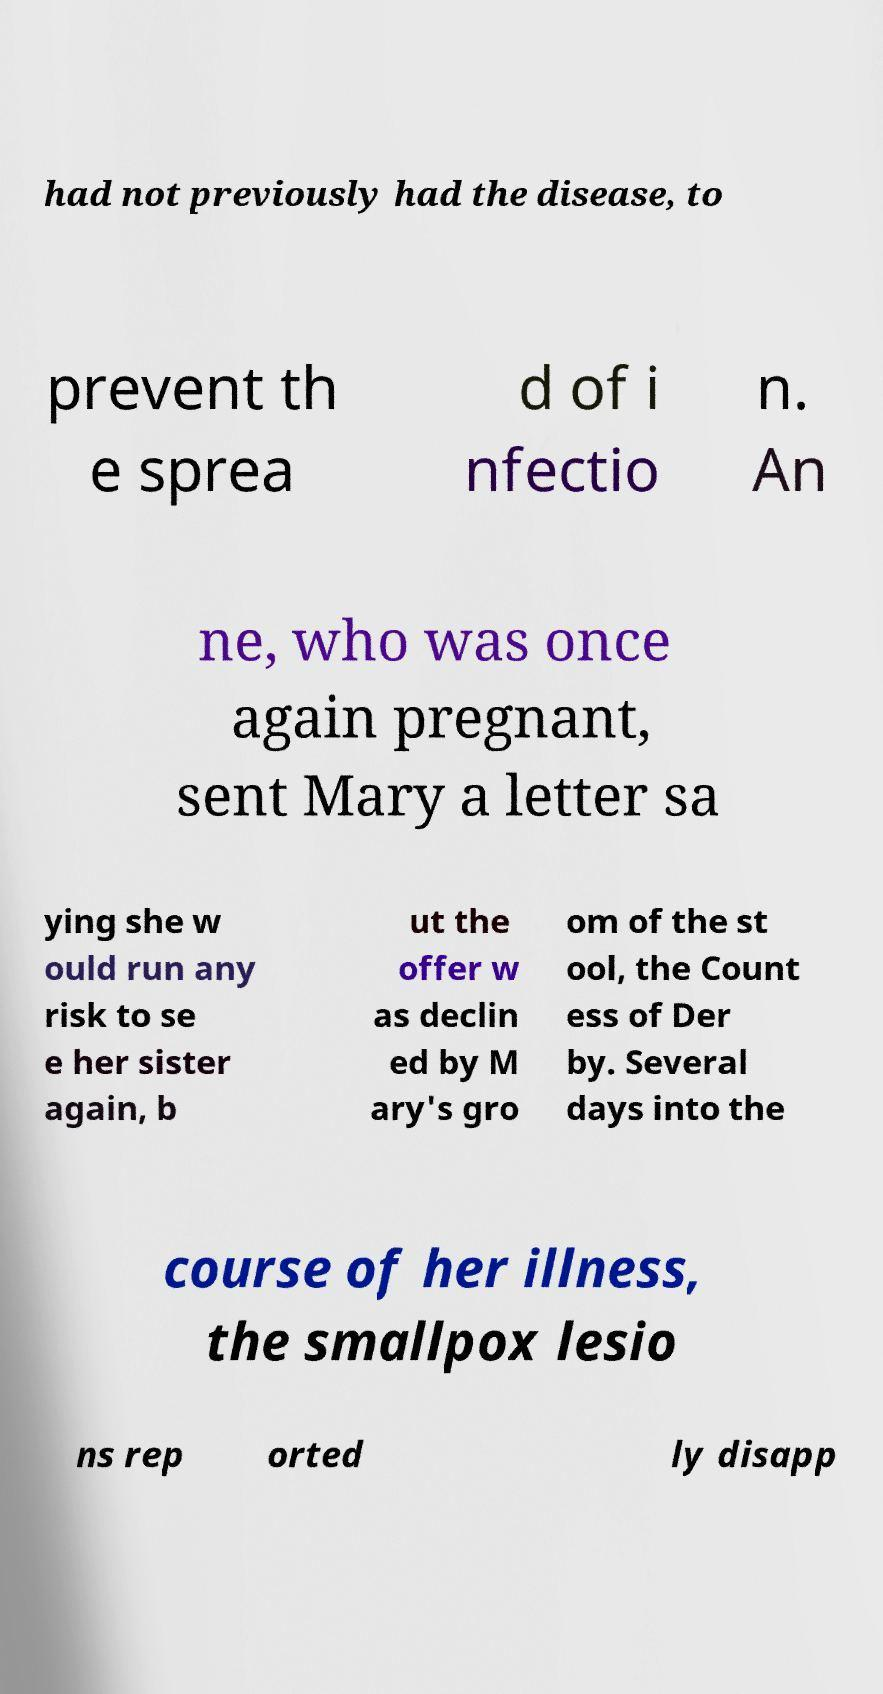I need the written content from this picture converted into text. Can you do that? had not previously had the disease, to prevent th e sprea d of i nfectio n. An ne, who was once again pregnant, sent Mary a letter sa ying she w ould run any risk to se e her sister again, b ut the offer w as declin ed by M ary's gro om of the st ool, the Count ess of Der by. Several days into the course of her illness, the smallpox lesio ns rep orted ly disapp 